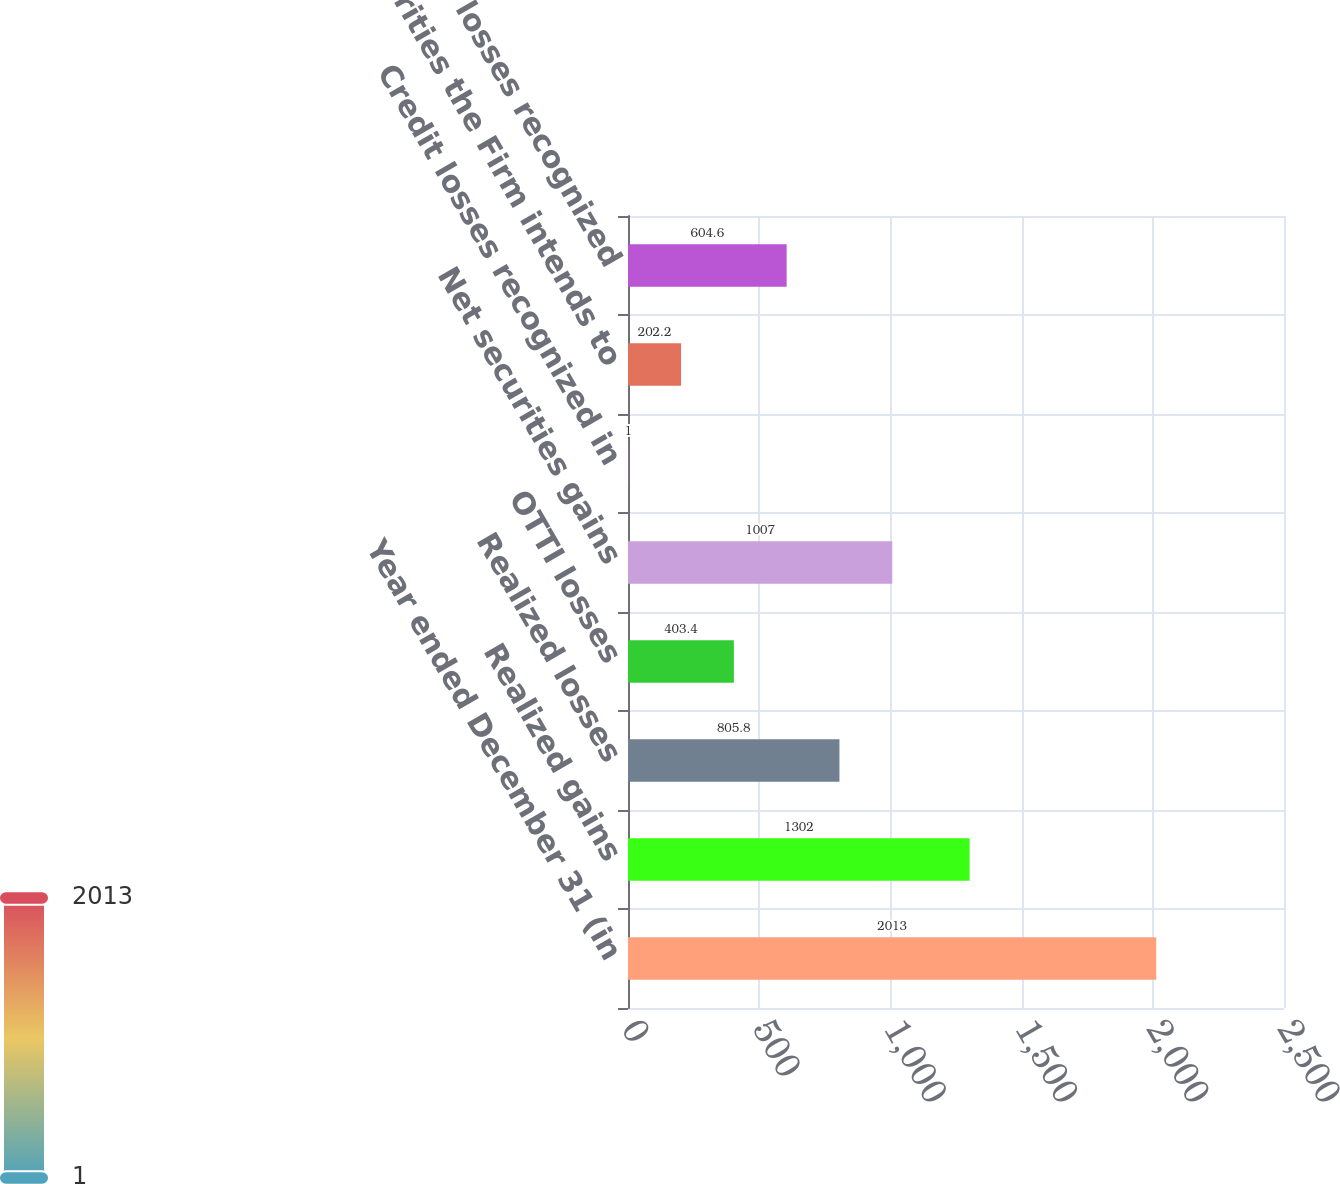Convert chart to OTSL. <chart><loc_0><loc_0><loc_500><loc_500><bar_chart><fcel>Year ended December 31 (in<fcel>Realized gains<fcel>Realized losses<fcel>OTTI losses<fcel>Net securities gains<fcel>Credit losses recognized in<fcel>Securities the Firm intends to<fcel>Total OTTI losses recognized<nl><fcel>2013<fcel>1302<fcel>805.8<fcel>403.4<fcel>1007<fcel>1<fcel>202.2<fcel>604.6<nl></chart> 